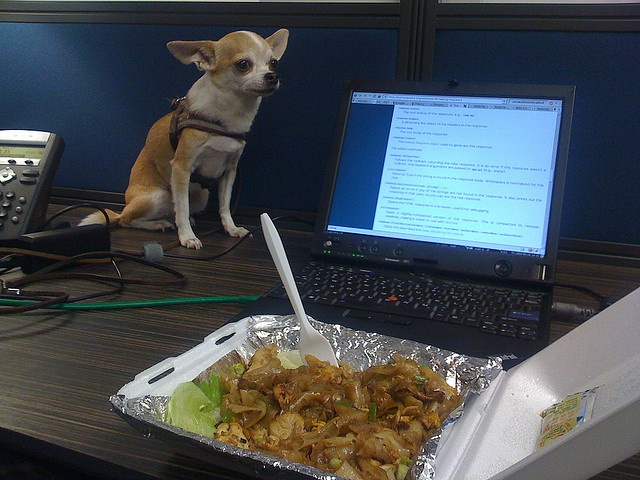Describe the objects in this image and their specific colors. I can see laptop in gray, black, lightblue, and navy tones, bowl in gray, olive, maroon, and black tones, dog in gray and black tones, and spoon in gray, darkgray, lightgray, and black tones in this image. 